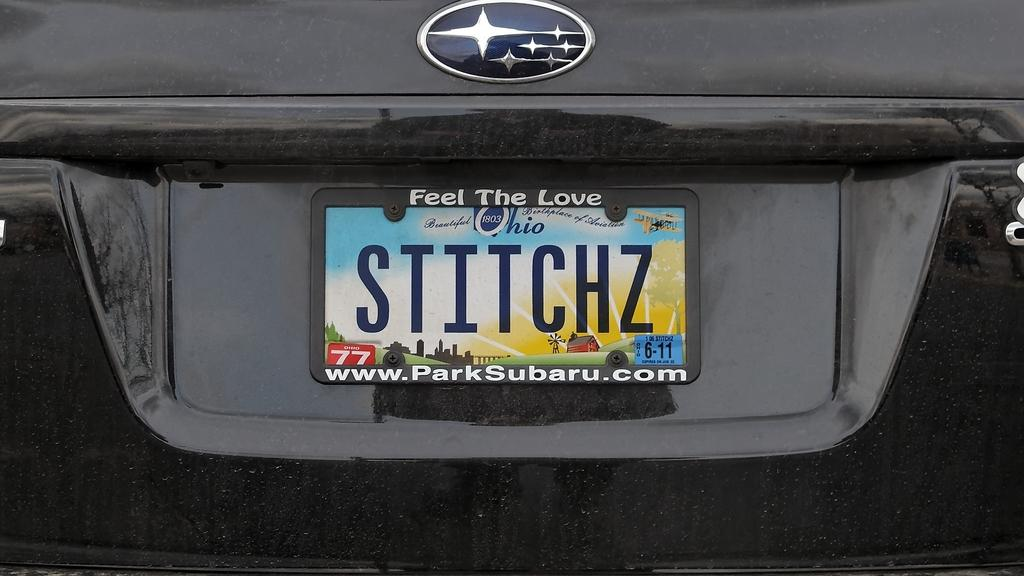<image>
Describe the image concisely. The license plate is from the state of Ohio. 